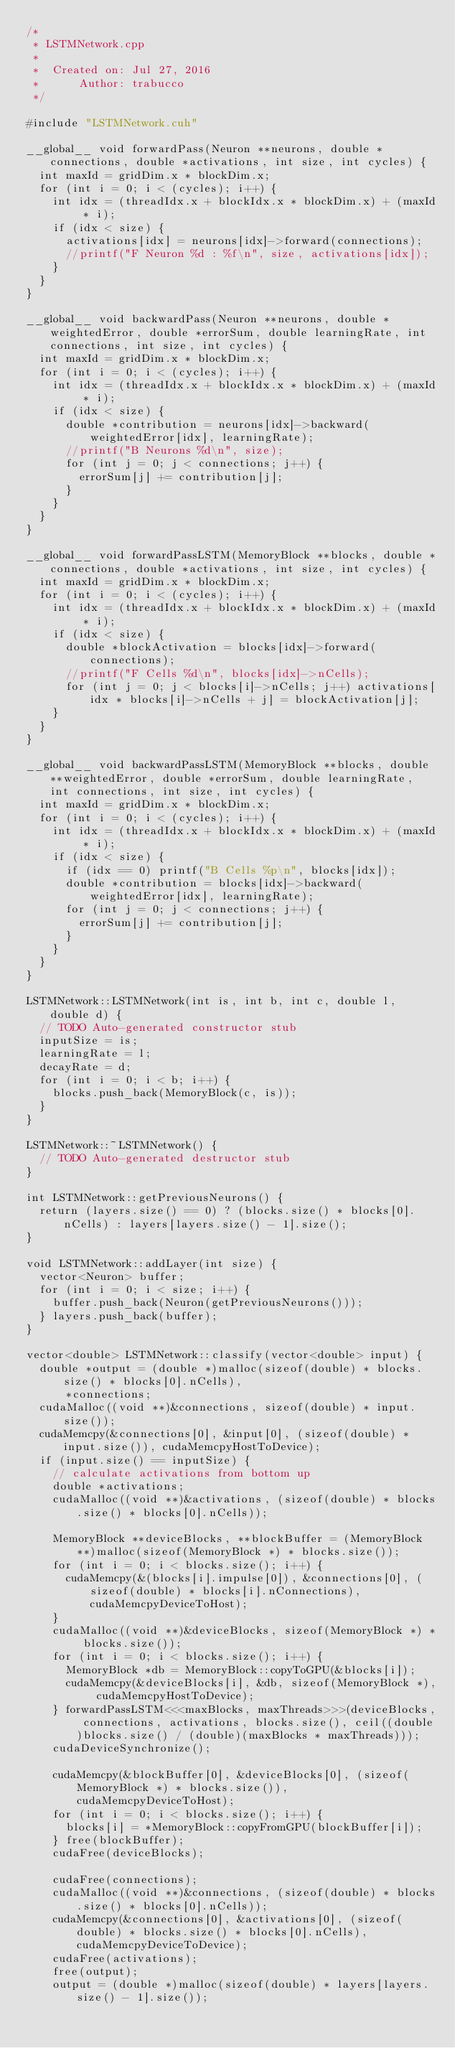<code> <loc_0><loc_0><loc_500><loc_500><_Cuda_>/*
 * LSTMNetwork.cpp
 *
 *  Created on: Jul 27, 2016
 *      Author: trabucco
 */

#include "LSTMNetwork.cuh"

__global__ void forwardPass(Neuron **neurons, double *connections, double *activations, int size, int cycles) {
	int maxId = gridDim.x * blockDim.x;
	for (int i = 0; i < (cycles); i++) {
		int idx = (threadIdx.x + blockIdx.x * blockDim.x) + (maxId * i);
		if (idx < size) {
			activations[idx] = neurons[idx]->forward(connections);
			//printf("F Neuron %d : %f\n", size, activations[idx]);
		}
	}
}

__global__ void backwardPass(Neuron **neurons, double *weightedError, double *errorSum, double learningRate, int connections, int size, int cycles) {
	int maxId = gridDim.x * blockDim.x;
	for (int i = 0; i < (cycles); i++) {
		int idx = (threadIdx.x + blockIdx.x * blockDim.x) + (maxId * i);
		if (idx < size) {
			double *contribution = neurons[idx]->backward(weightedError[idx], learningRate);
			//printf("B Neurons %d\n", size);
			for (int j = 0; j < connections; j++) {
				errorSum[j] += contribution[j];
			}
		}
	}
}

__global__ void forwardPassLSTM(MemoryBlock **blocks, double *connections, double *activations, int size, int cycles) {
	int maxId = gridDim.x * blockDim.x;
	for (int i = 0; i < (cycles); i++) {
		int idx = (threadIdx.x + blockIdx.x * blockDim.x) + (maxId * i);
		if (idx < size) {
			double *blockActivation = blocks[idx]->forward(connections);
			//printf("F Cells %d\n", blocks[idx]->nCells);
			for (int j = 0; j < blocks[i]->nCells; j++) activations[idx * blocks[i]->nCells + j] = blockActivation[j];
		}
	}
}

__global__ void backwardPassLSTM(MemoryBlock **blocks, double **weightedError, double *errorSum, double learningRate, int connections, int size, int cycles) {
	int maxId = gridDim.x * blockDim.x;
	for (int i = 0; i < (cycles); i++) {
		int idx = (threadIdx.x + blockIdx.x * blockDim.x) + (maxId * i);
		if (idx < size) {
			if (idx == 0) printf("B Cells %p\n", blocks[idx]);
			double *contribution = blocks[idx]->backward(weightedError[idx], learningRate);
			for (int j = 0; j < connections; j++) {
				errorSum[j] += contribution[j];
			}
		}
	}
}

LSTMNetwork::LSTMNetwork(int is, int b, int c, double l, double d) {
	// TODO Auto-generated constructor stub
	inputSize = is;
	learningRate = l;
	decayRate = d;
	for (int i = 0; i < b; i++) {
		blocks.push_back(MemoryBlock(c, is));
	}
}

LSTMNetwork::~LSTMNetwork() {
	// TODO Auto-generated destructor stub
}

int LSTMNetwork::getPreviousNeurons() {
	return (layers.size() == 0) ? (blocks.size() * blocks[0].nCells) : layers[layers.size() - 1].size();
}

void LSTMNetwork::addLayer(int size) {
	vector<Neuron> buffer;
	for (int i = 0; i < size; i++) {
		buffer.push_back(Neuron(getPreviousNeurons()));
	} layers.push_back(buffer);
}

vector<double> LSTMNetwork::classify(vector<double> input) {
	double *output = (double *)malloc(sizeof(double) * blocks.size() * blocks[0].nCells),
			*connections;
	cudaMalloc((void **)&connections, sizeof(double) * input.size());
	cudaMemcpy(&connections[0], &input[0], (sizeof(double) * input.size()), cudaMemcpyHostToDevice);
	if (input.size() == inputSize) {
		// calculate activations from bottom up
		double *activations;
		cudaMalloc((void **)&activations, (sizeof(double) * blocks.size() * blocks[0].nCells));

		MemoryBlock **deviceBlocks, **blockBuffer = (MemoryBlock **)malloc(sizeof(MemoryBlock *) * blocks.size());
		for (int i = 0; i < blocks.size(); i++) {
			cudaMemcpy(&(blocks[i].impulse[0]), &connections[0], (sizeof(double) * blocks[i].nConnections), cudaMemcpyDeviceToHost);
		}
		cudaMalloc((void **)&deviceBlocks, sizeof(MemoryBlock *) * blocks.size());
		for (int i = 0; i < blocks.size(); i++) {
			MemoryBlock *db = MemoryBlock::copyToGPU(&blocks[i]);
			cudaMemcpy(&deviceBlocks[i], &db, sizeof(MemoryBlock *), cudaMemcpyHostToDevice);
		} forwardPassLSTM<<<maxBlocks, maxThreads>>>(deviceBlocks, connections, activations, blocks.size(), ceil((double)blocks.size() / (double)(maxBlocks * maxThreads)));
		cudaDeviceSynchronize();

		cudaMemcpy(&blockBuffer[0], &deviceBlocks[0], (sizeof(MemoryBlock *) * blocks.size()), cudaMemcpyDeviceToHost);
		for (int i = 0; i < blocks.size(); i++) {
			blocks[i] = *MemoryBlock::copyFromGPU(blockBuffer[i]);
		} free(blockBuffer);
		cudaFree(deviceBlocks);

		cudaFree(connections);
		cudaMalloc((void **)&connections, (sizeof(double) * blocks.size() * blocks[0].nCells));
		cudaMemcpy(&connections[0], &activations[0], (sizeof(double) * blocks.size() * blocks[0].nCells), cudaMemcpyDeviceToDevice);
		cudaFree(activations);
		free(output);
		output = (double *)malloc(sizeof(double) * layers[layers.size() - 1].size());
</code> 